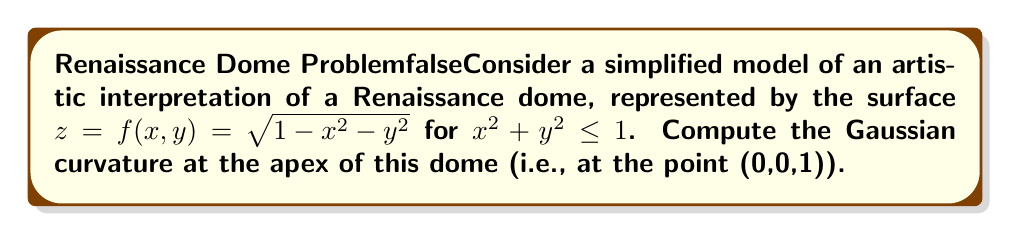Provide a solution to this math problem. To compute the Gaussian curvature, we need to follow these steps:

1) The Gaussian curvature K is given by:

   $$ K = \frac{LN - M^2}{EG - F^2} $$

   where L, M, N are the coefficients of the second fundamental form, and E, F, G are the coefficients of the first fundamental form.

2) For a surface given by $z = f(x,y)$, we have:

   $$ E = 1 + f_x^2, \quad F = f_x f_y, \quad G = 1 + f_y^2 $$
   $$ L = \frac{f_{xx}}{\sqrt{1 + f_x^2 + f_y^2}}, \quad M = \frac{f_{xy}}{\sqrt{1 + f_x^2 + f_y^2}}, \quad N = \frac{f_{yy}}{\sqrt{1 + f_x^2 + f_y^2}} $$

3) Let's compute the partial derivatives:

   $$ f_x = -\frac{x}{\sqrt{1-x^2-y^2}}, \quad f_y = -\frac{y}{\sqrt{1-x^2-y^2}} $$
   $$ f_{xx} = -\frac{1-y^2}{(1-x^2-y^2)^{3/2}}, \quad f_{yy} = -\frac{1-x^2}{(1-x^2-y^2)^{3/2}}, \quad f_{xy} = \frac{xy}{(1-x^2-y^2)^{3/2}} $$

4) At the apex (0,0,1), these simplify to:

   $$ f_x = f_y = 0, \quad f_{xx} = f_{yy} = -1, \quad f_{xy} = 0 $$

5) Substituting into the formulas for E, F, G, L, M, N:

   $$ E = G = 1, \quad F = 0 $$
   $$ L = N = -1, \quad M = 0 $$

6) Finally, we can compute the Gaussian curvature:

   $$ K = \frac{LN - M^2}{EG - F^2} = \frac{(-1)(-1) - 0^2}{(1)(1) - 0^2} = 1 $$

Thus, the Gaussian curvature at the apex of the dome is 1.
Answer: The Gaussian curvature at the apex of the dome is 1. 